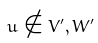<formula> <loc_0><loc_0><loc_500><loc_500>u \notin V ^ { \prime } , W ^ { \prime }</formula> 